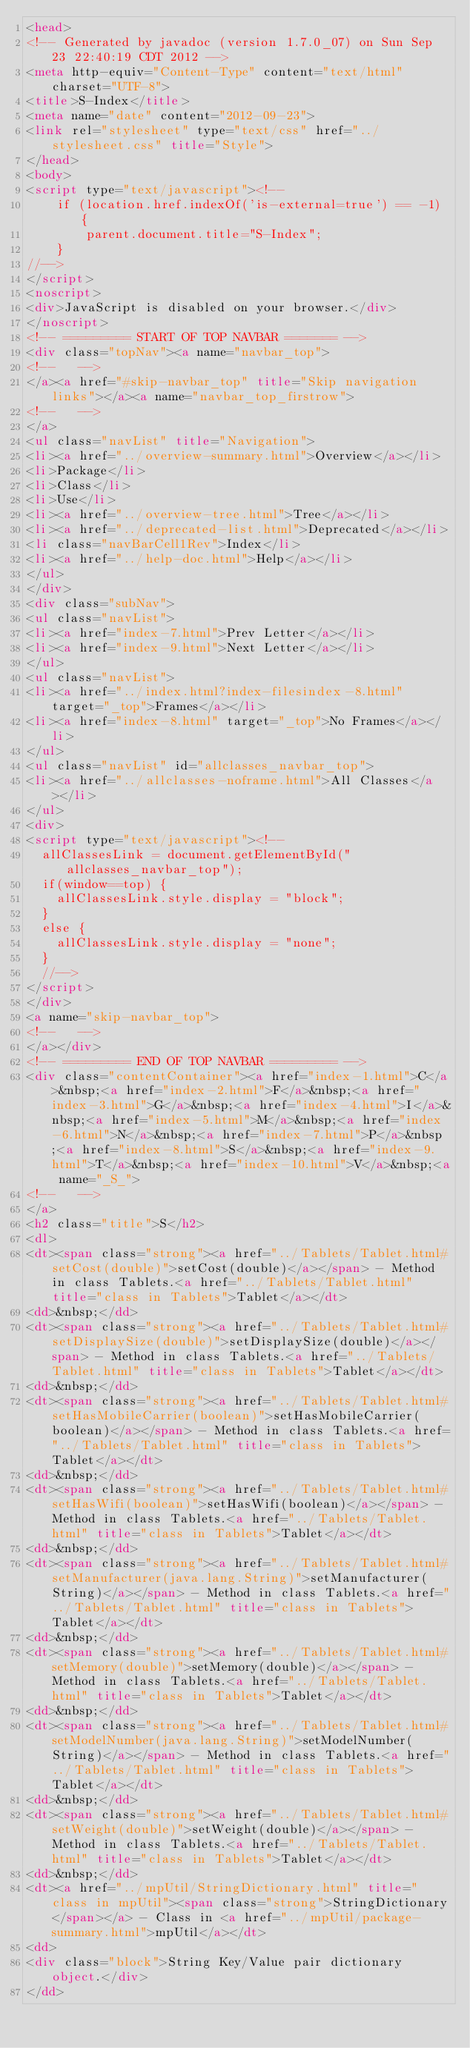<code> <loc_0><loc_0><loc_500><loc_500><_HTML_><head>
<!-- Generated by javadoc (version 1.7.0_07) on Sun Sep 23 22:40:19 CDT 2012 -->
<meta http-equiv="Content-Type" content="text/html" charset="UTF-8">
<title>S-Index</title>
<meta name="date" content="2012-09-23">
<link rel="stylesheet" type="text/css" href="../stylesheet.css" title="Style">
</head>
<body>
<script type="text/javascript"><!--
    if (location.href.indexOf('is-external=true') == -1) {
        parent.document.title="S-Index";
    }
//-->
</script>
<noscript>
<div>JavaScript is disabled on your browser.</div>
</noscript>
<!-- ========= START OF TOP NAVBAR ======= -->
<div class="topNav"><a name="navbar_top">
<!--   -->
</a><a href="#skip-navbar_top" title="Skip navigation links"></a><a name="navbar_top_firstrow">
<!--   -->
</a>
<ul class="navList" title="Navigation">
<li><a href="../overview-summary.html">Overview</a></li>
<li>Package</li>
<li>Class</li>
<li>Use</li>
<li><a href="../overview-tree.html">Tree</a></li>
<li><a href="../deprecated-list.html">Deprecated</a></li>
<li class="navBarCell1Rev">Index</li>
<li><a href="../help-doc.html">Help</a></li>
</ul>
</div>
<div class="subNav">
<ul class="navList">
<li><a href="index-7.html">Prev Letter</a></li>
<li><a href="index-9.html">Next Letter</a></li>
</ul>
<ul class="navList">
<li><a href="../index.html?index-filesindex-8.html" target="_top">Frames</a></li>
<li><a href="index-8.html" target="_top">No Frames</a></li>
</ul>
<ul class="navList" id="allclasses_navbar_top">
<li><a href="../allclasses-noframe.html">All Classes</a></li>
</ul>
<div>
<script type="text/javascript"><!--
  allClassesLink = document.getElementById("allclasses_navbar_top");
  if(window==top) {
    allClassesLink.style.display = "block";
  }
  else {
    allClassesLink.style.display = "none";
  }
  //-->
</script>
</div>
<a name="skip-navbar_top">
<!--   -->
</a></div>
<!-- ========= END OF TOP NAVBAR ========= -->
<div class="contentContainer"><a href="index-1.html">C</a>&nbsp;<a href="index-2.html">F</a>&nbsp;<a href="index-3.html">G</a>&nbsp;<a href="index-4.html">I</a>&nbsp;<a href="index-5.html">M</a>&nbsp;<a href="index-6.html">N</a>&nbsp;<a href="index-7.html">P</a>&nbsp;<a href="index-8.html">S</a>&nbsp;<a href="index-9.html">T</a>&nbsp;<a href="index-10.html">V</a>&nbsp;<a name="_S_">
<!--   -->
</a>
<h2 class="title">S</h2>
<dl>
<dt><span class="strong"><a href="../Tablets/Tablet.html#setCost(double)">setCost(double)</a></span> - Method in class Tablets.<a href="../Tablets/Tablet.html" title="class in Tablets">Tablet</a></dt>
<dd>&nbsp;</dd>
<dt><span class="strong"><a href="../Tablets/Tablet.html#setDisplaySize(double)">setDisplaySize(double)</a></span> - Method in class Tablets.<a href="../Tablets/Tablet.html" title="class in Tablets">Tablet</a></dt>
<dd>&nbsp;</dd>
<dt><span class="strong"><a href="../Tablets/Tablet.html#setHasMobileCarrier(boolean)">setHasMobileCarrier(boolean)</a></span> - Method in class Tablets.<a href="../Tablets/Tablet.html" title="class in Tablets">Tablet</a></dt>
<dd>&nbsp;</dd>
<dt><span class="strong"><a href="../Tablets/Tablet.html#setHasWifi(boolean)">setHasWifi(boolean)</a></span> - Method in class Tablets.<a href="../Tablets/Tablet.html" title="class in Tablets">Tablet</a></dt>
<dd>&nbsp;</dd>
<dt><span class="strong"><a href="../Tablets/Tablet.html#setManufacturer(java.lang.String)">setManufacturer(String)</a></span> - Method in class Tablets.<a href="../Tablets/Tablet.html" title="class in Tablets">Tablet</a></dt>
<dd>&nbsp;</dd>
<dt><span class="strong"><a href="../Tablets/Tablet.html#setMemory(double)">setMemory(double)</a></span> - Method in class Tablets.<a href="../Tablets/Tablet.html" title="class in Tablets">Tablet</a></dt>
<dd>&nbsp;</dd>
<dt><span class="strong"><a href="../Tablets/Tablet.html#setModelNumber(java.lang.String)">setModelNumber(String)</a></span> - Method in class Tablets.<a href="../Tablets/Tablet.html" title="class in Tablets">Tablet</a></dt>
<dd>&nbsp;</dd>
<dt><span class="strong"><a href="../Tablets/Tablet.html#setWeight(double)">setWeight(double)</a></span> - Method in class Tablets.<a href="../Tablets/Tablet.html" title="class in Tablets">Tablet</a></dt>
<dd>&nbsp;</dd>
<dt><a href="../mpUtil/StringDictionary.html" title="class in mpUtil"><span class="strong">StringDictionary</span></a> - Class in <a href="../mpUtil/package-summary.html">mpUtil</a></dt>
<dd>
<div class="block">String Key/Value pair dictionary object.</div>
</dd></code> 